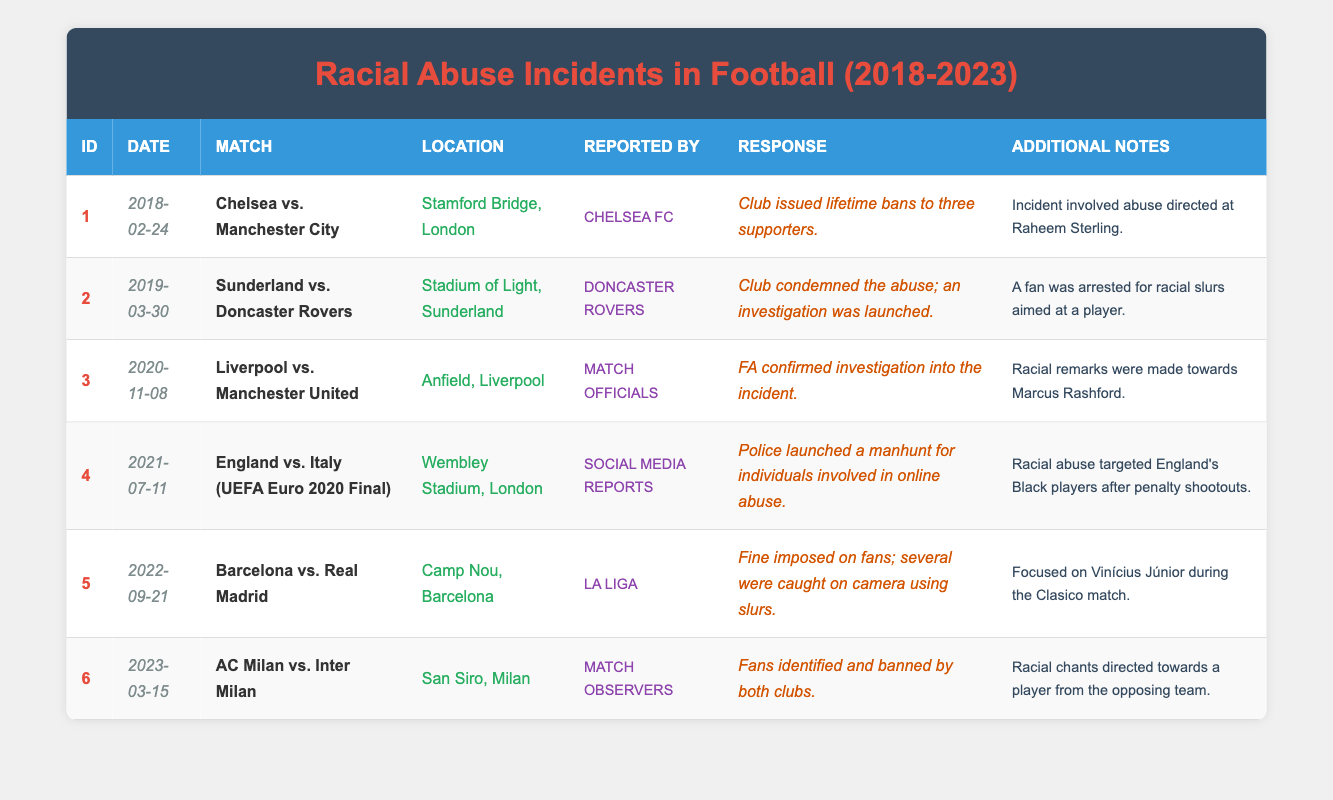What incident occurred on 2021-07-11? The table shows that on July 11, 2021, the match between England and Italy took place at Wembley Stadium. The incident reported was about racial abuse directed towards England’s Black players after the penalty shootouts during the UEFA Euro 2020 Final.
Answer: Racial abuse targeting England's Black players How many incidents were reported by "Chelsea FC"? Only one incident is recorded in the table that was reported by Chelsea FC, which was on February 24, 2018, involving the match between Chelsea and Manchester City.
Answer: One incident Was a fan arrested during the incident on March 30, 2019? The data indicates that during the incident on March 30, 2019, related to the match between Sunderland and Doncaster Rovers, a fan was indeed arrested for racial slurs aimed at a player.
Answer: Yes What is the response given by clubs involved in incidents targeting a player? The response for the incidents that directly targeted players included various actions: in one case, Chelsea issued lifetime bans to supporters, and in another case, both AC Milan and Inter Milan identified and banned fans involved. Hence, the clubs took stringent actions against the involved supporters.
Answer: Clubs took strict actions like lifetime bans and identifying offenders How many of the incidents involved investigations? By reviewing the table, there are four incidents explicitly stated that had investigations: Chelsea vs. Manchester City (2018), Sunderland vs. Doncaster Rovers (2019), Liverpool vs. Manchester United (2020), and the UEFA Euro 2020 Final (2021). This determines that multiple steps of matching reported incidents with those that were under investigations led to the conclusion.
Answer: Four incidents 